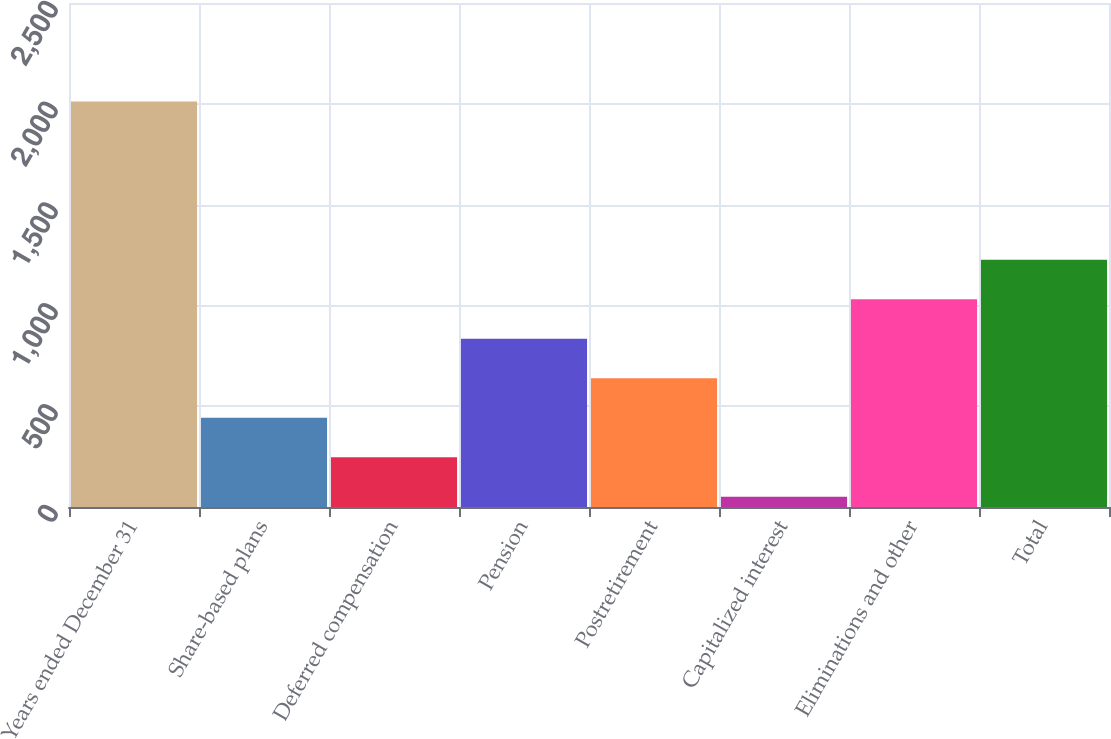<chart> <loc_0><loc_0><loc_500><loc_500><bar_chart><fcel>Years ended December 31<fcel>Share-based plans<fcel>Deferred compensation<fcel>Pension<fcel>Postretirement<fcel>Capitalized interest<fcel>Eliminations and other<fcel>Total<nl><fcel>2011<fcel>443<fcel>247<fcel>835<fcel>639<fcel>51<fcel>1031<fcel>1227<nl></chart> 